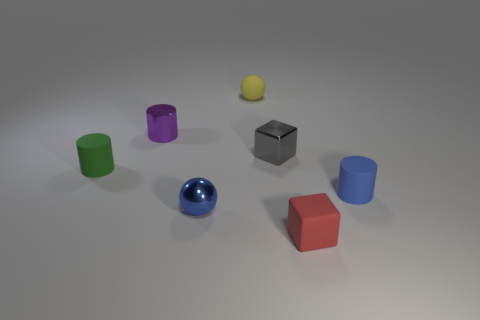How many other things are the same shape as the purple thing?
Provide a short and direct response. 2. There is a cube that is behind the tiny matte thing that is in front of the matte cylinder in front of the tiny green cylinder; what is it made of?
Your answer should be compact. Metal. Does the tiny red object have the same material as the blue object behind the tiny blue ball?
Your answer should be compact. Yes. Is the number of small gray metallic blocks that are right of the blue matte cylinder less than the number of tiny shiny blocks to the right of the small shiny cube?
Your answer should be very brief. No. How many cyan spheres have the same material as the small red block?
Make the answer very short. 0. There is a block that is behind the tiny matte cylinder on the right side of the small metallic cylinder; are there any tiny gray shiny objects that are left of it?
Ensure brevity in your answer.  No. How many cubes are tiny yellow objects or purple metal objects?
Offer a terse response. 0. Does the tiny purple object have the same shape as the tiny matte thing that is on the left side of the yellow ball?
Your response must be concise. Yes. Are there fewer purple cylinders to the right of the gray block than tiny matte cylinders?
Offer a terse response. Yes. Are there any small red cubes to the left of the blue shiny thing?
Your answer should be compact. No. 